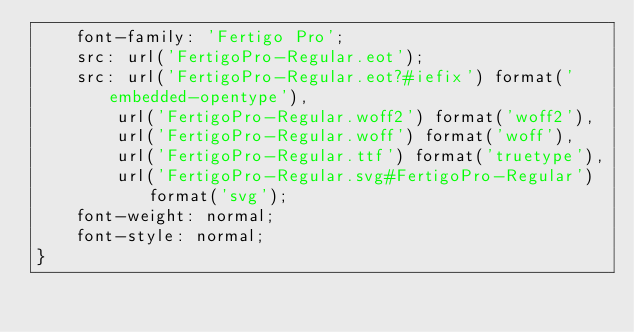<code> <loc_0><loc_0><loc_500><loc_500><_CSS_>    font-family: 'Fertigo Pro';
    src: url('FertigoPro-Regular.eot');
    src: url('FertigoPro-Regular.eot?#iefix') format('embedded-opentype'),
        url('FertigoPro-Regular.woff2') format('woff2'),
        url('FertigoPro-Regular.woff') format('woff'),
        url('FertigoPro-Regular.ttf') format('truetype'),
        url('FertigoPro-Regular.svg#FertigoPro-Regular') format('svg');
    font-weight: normal;
    font-style: normal;
}

</code> 